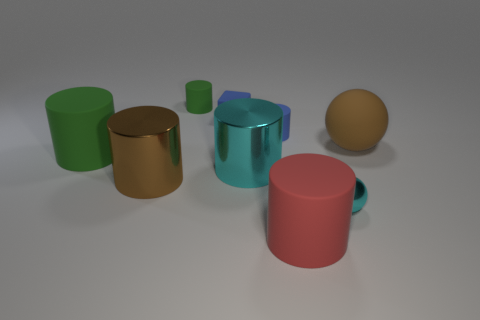Imagine these objects are part of a product design, what could be their function? The cylinder and cups might serve as containers or vessels for liquids or small items in a product line. The sphere could be decorative or perhaps part of a game set. If these objects were scaled down, they could be part of a modern, minimalist tabletop collection. 